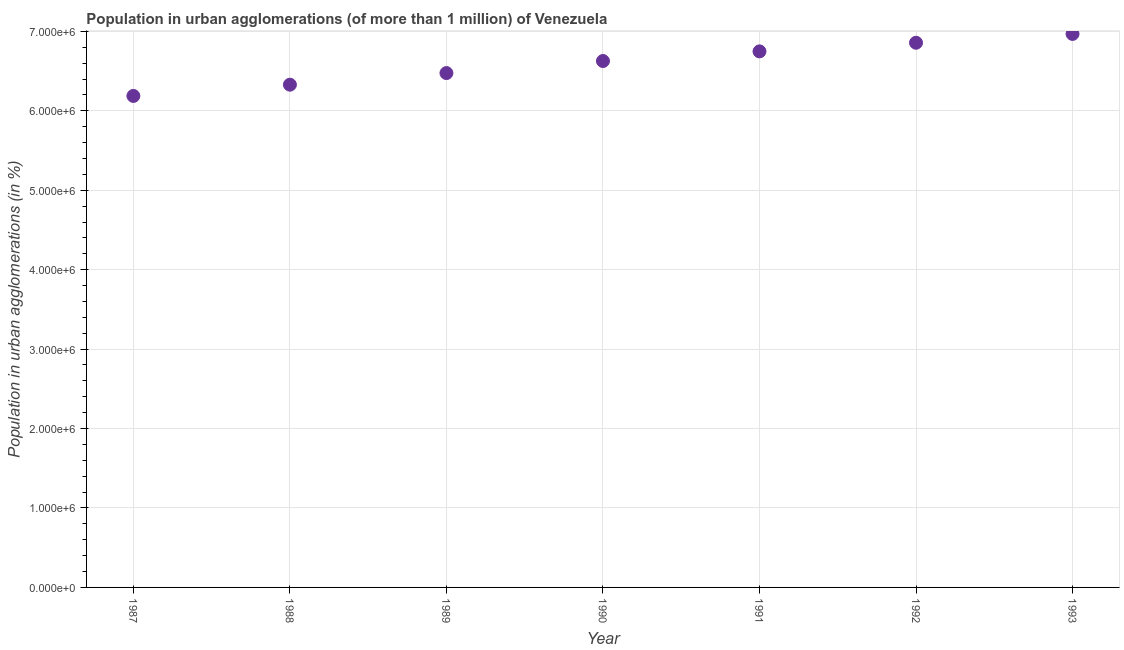What is the population in urban agglomerations in 1991?
Give a very brief answer. 6.75e+06. Across all years, what is the maximum population in urban agglomerations?
Give a very brief answer. 6.97e+06. Across all years, what is the minimum population in urban agglomerations?
Provide a short and direct response. 6.19e+06. In which year was the population in urban agglomerations minimum?
Make the answer very short. 1987. What is the sum of the population in urban agglomerations?
Make the answer very short. 4.62e+07. What is the difference between the population in urban agglomerations in 1992 and 1993?
Keep it short and to the point. -1.11e+05. What is the average population in urban agglomerations per year?
Your response must be concise. 6.60e+06. What is the median population in urban agglomerations?
Your answer should be very brief. 6.63e+06. What is the ratio of the population in urban agglomerations in 1990 to that in 1993?
Keep it short and to the point. 0.95. Is the difference between the population in urban agglomerations in 1991 and 1993 greater than the difference between any two years?
Provide a short and direct response. No. What is the difference between the highest and the second highest population in urban agglomerations?
Your response must be concise. 1.11e+05. What is the difference between the highest and the lowest population in urban agglomerations?
Your answer should be compact. 7.81e+05. Does the population in urban agglomerations monotonically increase over the years?
Provide a succinct answer. Yes. How many dotlines are there?
Keep it short and to the point. 1. How many years are there in the graph?
Ensure brevity in your answer.  7. Are the values on the major ticks of Y-axis written in scientific E-notation?
Keep it short and to the point. Yes. Does the graph contain grids?
Give a very brief answer. Yes. What is the title of the graph?
Your answer should be very brief. Population in urban agglomerations (of more than 1 million) of Venezuela. What is the label or title of the X-axis?
Provide a short and direct response. Year. What is the label or title of the Y-axis?
Offer a very short reply. Population in urban agglomerations (in %). What is the Population in urban agglomerations (in %) in 1987?
Give a very brief answer. 6.19e+06. What is the Population in urban agglomerations (in %) in 1988?
Your response must be concise. 6.33e+06. What is the Population in urban agglomerations (in %) in 1989?
Your answer should be compact. 6.47e+06. What is the Population in urban agglomerations (in %) in 1990?
Offer a terse response. 6.63e+06. What is the Population in urban agglomerations (in %) in 1991?
Offer a very short reply. 6.75e+06. What is the Population in urban agglomerations (in %) in 1992?
Keep it short and to the point. 6.86e+06. What is the Population in urban agglomerations (in %) in 1993?
Make the answer very short. 6.97e+06. What is the difference between the Population in urban agglomerations (in %) in 1987 and 1988?
Provide a short and direct response. -1.42e+05. What is the difference between the Population in urban agglomerations (in %) in 1987 and 1989?
Ensure brevity in your answer.  -2.88e+05. What is the difference between the Population in urban agglomerations (in %) in 1987 and 1990?
Your answer should be compact. -4.40e+05. What is the difference between the Population in urban agglomerations (in %) in 1987 and 1991?
Ensure brevity in your answer.  -5.61e+05. What is the difference between the Population in urban agglomerations (in %) in 1987 and 1992?
Keep it short and to the point. -6.70e+05. What is the difference between the Population in urban agglomerations (in %) in 1987 and 1993?
Offer a very short reply. -7.81e+05. What is the difference between the Population in urban agglomerations (in %) in 1988 and 1989?
Offer a terse response. -1.46e+05. What is the difference between the Population in urban agglomerations (in %) in 1988 and 1990?
Make the answer very short. -2.98e+05. What is the difference between the Population in urban agglomerations (in %) in 1988 and 1991?
Provide a short and direct response. -4.19e+05. What is the difference between the Population in urban agglomerations (in %) in 1988 and 1992?
Provide a short and direct response. -5.28e+05. What is the difference between the Population in urban agglomerations (in %) in 1988 and 1993?
Ensure brevity in your answer.  -6.39e+05. What is the difference between the Population in urban agglomerations (in %) in 1989 and 1990?
Ensure brevity in your answer.  -1.52e+05. What is the difference between the Population in urban agglomerations (in %) in 1989 and 1991?
Keep it short and to the point. -2.73e+05. What is the difference between the Population in urban agglomerations (in %) in 1989 and 1992?
Ensure brevity in your answer.  -3.82e+05. What is the difference between the Population in urban agglomerations (in %) in 1989 and 1993?
Ensure brevity in your answer.  -4.93e+05. What is the difference between the Population in urban agglomerations (in %) in 1990 and 1991?
Your answer should be compact. -1.21e+05. What is the difference between the Population in urban agglomerations (in %) in 1990 and 1992?
Keep it short and to the point. -2.30e+05. What is the difference between the Population in urban agglomerations (in %) in 1990 and 1993?
Offer a very short reply. -3.41e+05. What is the difference between the Population in urban agglomerations (in %) in 1991 and 1992?
Your answer should be very brief. -1.09e+05. What is the difference between the Population in urban agglomerations (in %) in 1991 and 1993?
Offer a terse response. -2.20e+05. What is the difference between the Population in urban agglomerations (in %) in 1992 and 1993?
Keep it short and to the point. -1.11e+05. What is the ratio of the Population in urban agglomerations (in %) in 1987 to that in 1988?
Ensure brevity in your answer.  0.98. What is the ratio of the Population in urban agglomerations (in %) in 1987 to that in 1989?
Provide a succinct answer. 0.96. What is the ratio of the Population in urban agglomerations (in %) in 1987 to that in 1990?
Ensure brevity in your answer.  0.93. What is the ratio of the Population in urban agglomerations (in %) in 1987 to that in 1991?
Keep it short and to the point. 0.92. What is the ratio of the Population in urban agglomerations (in %) in 1987 to that in 1992?
Your response must be concise. 0.9. What is the ratio of the Population in urban agglomerations (in %) in 1987 to that in 1993?
Provide a succinct answer. 0.89. What is the ratio of the Population in urban agglomerations (in %) in 1988 to that in 1990?
Make the answer very short. 0.95. What is the ratio of the Population in urban agglomerations (in %) in 1988 to that in 1991?
Provide a succinct answer. 0.94. What is the ratio of the Population in urban agglomerations (in %) in 1988 to that in 1992?
Your answer should be very brief. 0.92. What is the ratio of the Population in urban agglomerations (in %) in 1988 to that in 1993?
Provide a succinct answer. 0.91. What is the ratio of the Population in urban agglomerations (in %) in 1989 to that in 1990?
Your response must be concise. 0.98. What is the ratio of the Population in urban agglomerations (in %) in 1989 to that in 1991?
Your answer should be compact. 0.96. What is the ratio of the Population in urban agglomerations (in %) in 1989 to that in 1992?
Keep it short and to the point. 0.94. What is the ratio of the Population in urban agglomerations (in %) in 1989 to that in 1993?
Provide a short and direct response. 0.93. What is the ratio of the Population in urban agglomerations (in %) in 1990 to that in 1993?
Offer a terse response. 0.95. What is the ratio of the Population in urban agglomerations (in %) in 1991 to that in 1993?
Your answer should be compact. 0.97. What is the ratio of the Population in urban agglomerations (in %) in 1992 to that in 1993?
Ensure brevity in your answer.  0.98. 